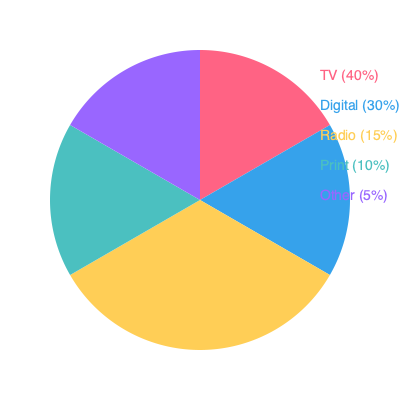Based on the pie chart showing the breakdown of advertising mediums used in political campaigns, what percentage of the budget is allocated to traditional media (TV, radio, and print) compared to digital advertising? To answer this question, we need to follow these steps:

1. Identify the traditional media components:
   - TV: 40%
   - Radio: 15%
   - Print: 10%

2. Calculate the total percentage for traditional media:
   $40\% + 15\% + 10\% = 65\%$

3. Identify the percentage for digital advertising:
   - Digital: 30%

4. Compare traditional media to digital advertising:
   Traditional media (65%) is greater than digital advertising (30%) by 35 percentage points.

5. Calculate the ratio:
   $\frac{65\%}{30\%} \approx 2.17$

This means that traditional media receives about 2.17 times more budget allocation than digital advertising in political campaigns.
Answer: 65% vs. 30%, or 2.17:1 ratio 